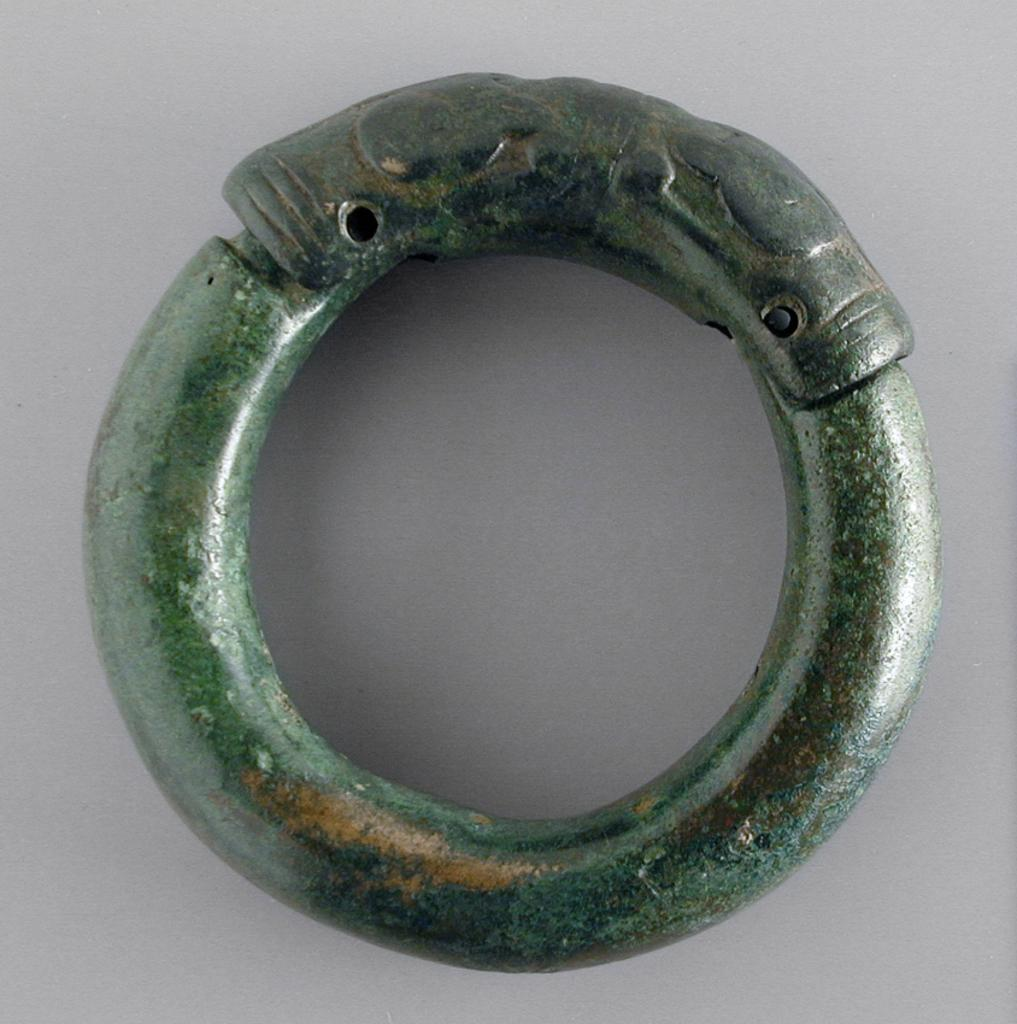What object can be seen in the image? There is a ring in the image. What material is the ring made of? The ring is made up of iron. What historical event is depicted in the image involving a zephyr and a van? There is no historical event, zephyr, or van present in the image. The image only contains a ring made of iron. 